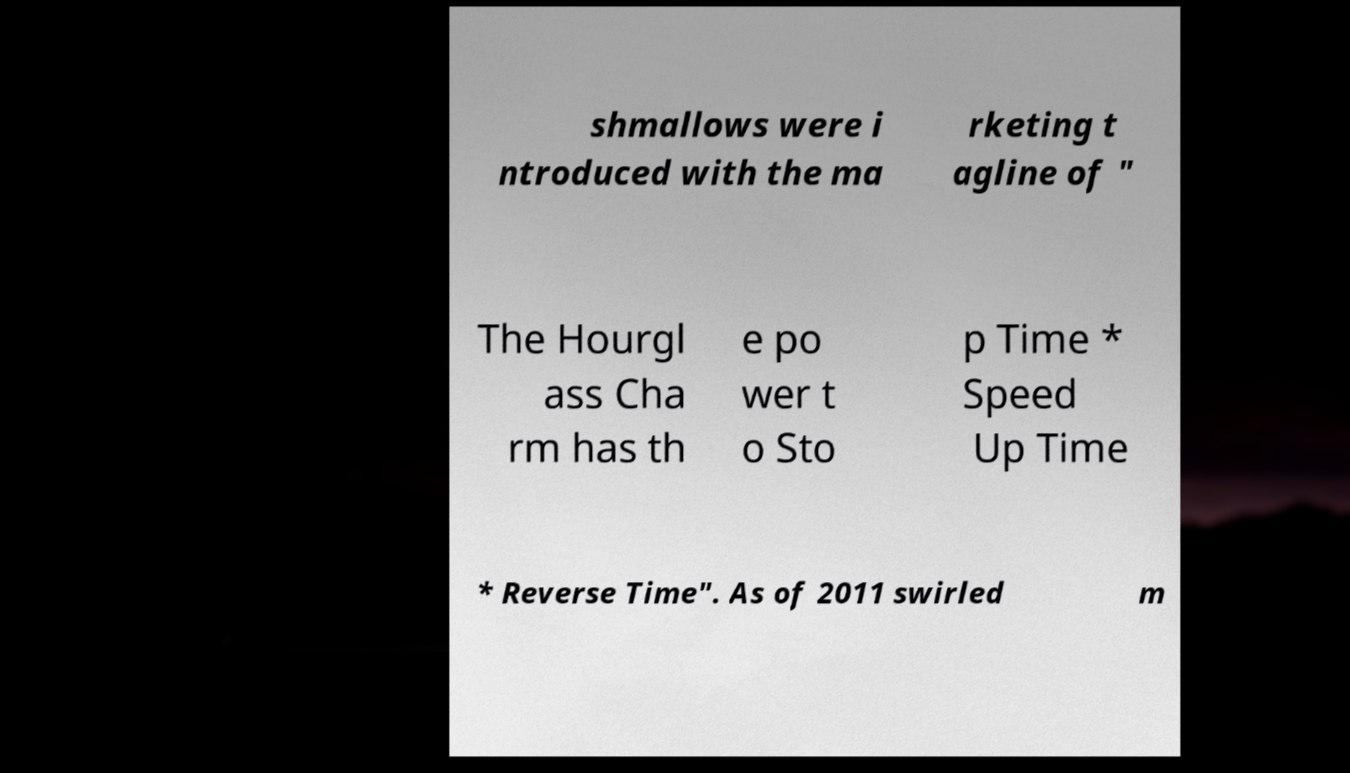Can you read and provide the text displayed in the image?This photo seems to have some interesting text. Can you extract and type it out for me? shmallows were i ntroduced with the ma rketing t agline of " The Hourgl ass Cha rm has th e po wer t o Sto p Time * Speed Up Time * Reverse Time". As of 2011 swirled m 